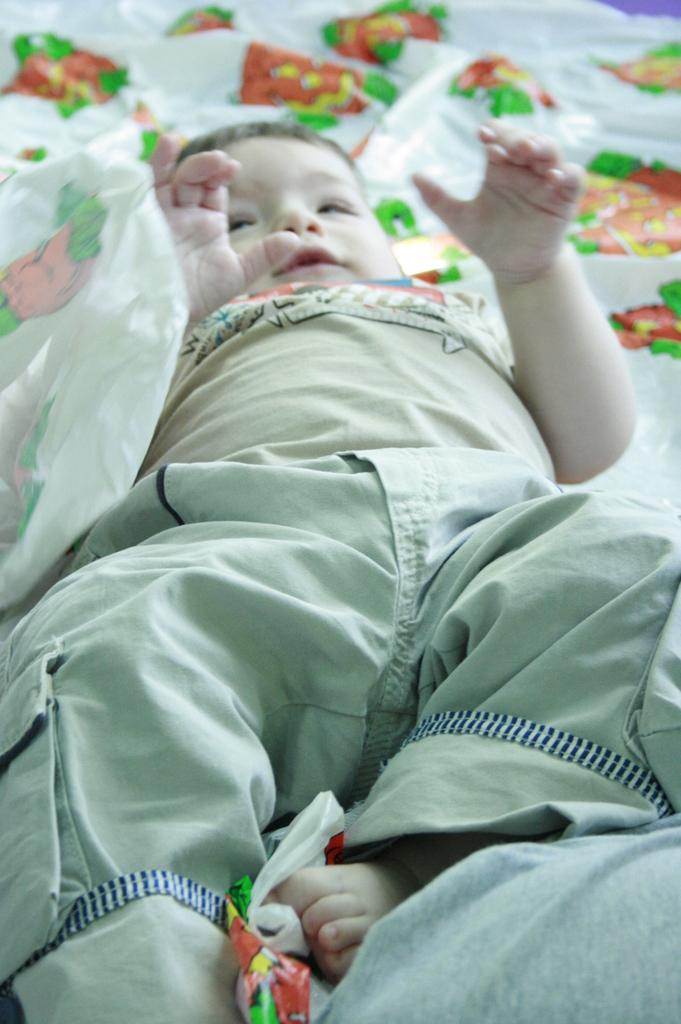What is the main subject of the image? There is a kid in the center of the image. What is the kid's position in the image? The kid is lying on a bed. What can be seen in the background of the image? There are plastic papers in the background of the image. What type of loaf is the kid holding in the image? There is no loaf present in the image; the kid is lying on a bed. How much coal is visible in the image? There is no coal present in the image. 